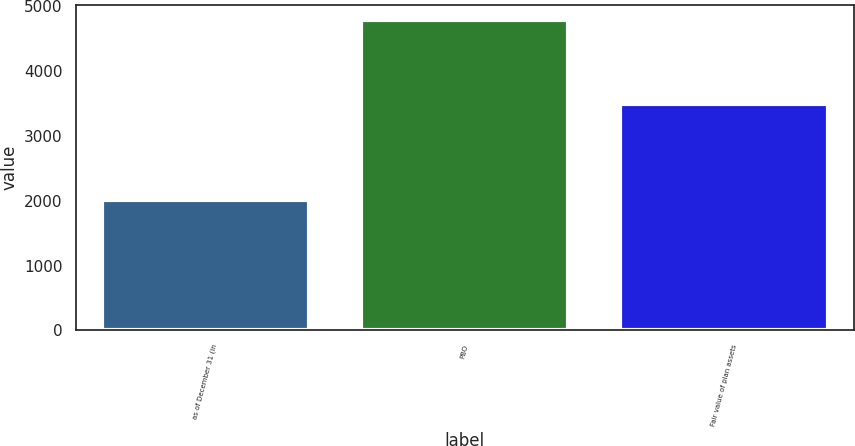Convert chart. <chart><loc_0><loc_0><loc_500><loc_500><bar_chart><fcel>as of December 31 (in<fcel>PBO<fcel>Fair value of plan assets<nl><fcel>2011<fcel>4783<fcel>3487<nl></chart> 